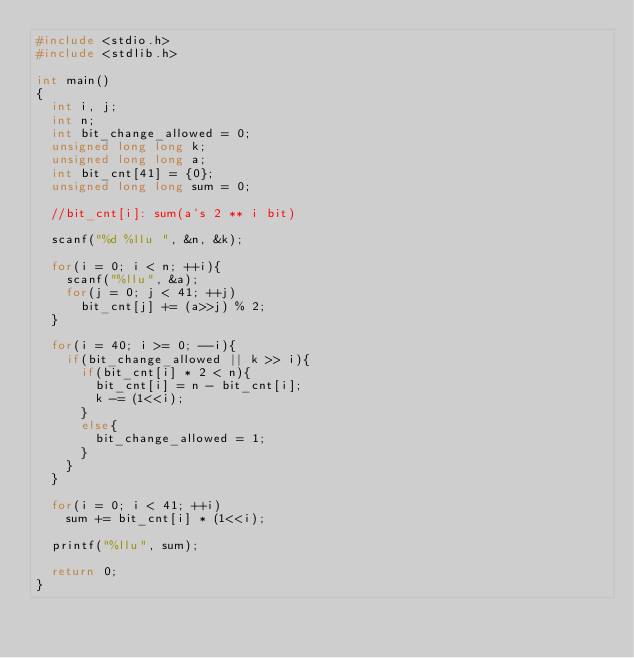<code> <loc_0><loc_0><loc_500><loc_500><_C_>#include <stdio.h>
#include <stdlib.h>

int main()
{
	int i, j;
	int n;
	int bit_change_allowed = 0;
	unsigned long long k;
	unsigned long long a;
	int bit_cnt[41] = {0};
	unsigned long long sum = 0;
	
	//bit_cnt[i]: sum(a's 2 ** i bit)
	
	scanf("%d %llu ", &n, &k);
	
	for(i = 0; i < n; ++i){
		scanf("%llu", &a);
		for(j = 0; j < 41; ++j)
			bit_cnt[j] += (a>>j) % 2;
	}
	
	for(i = 40; i >= 0; --i){
		if(bit_change_allowed || k >> i){
			if(bit_cnt[i] * 2 < n){
				bit_cnt[i] = n - bit_cnt[i];
				k -= (1<<i);	
			}
			else{
				bit_change_allowed = 1;
			}
		}
	}
	
	for(i = 0; i < 41; ++i)
		sum += bit_cnt[i] * (1<<i);
	
	printf("%llu", sum);
	
	return 0;
}
</code> 